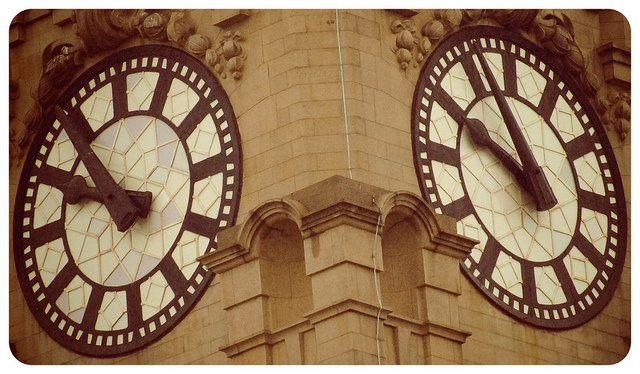Describe the objects in this image and their specific colors. I can see clock in white, maroon, and tan tones and clock in white, maroon, and tan tones in this image. 